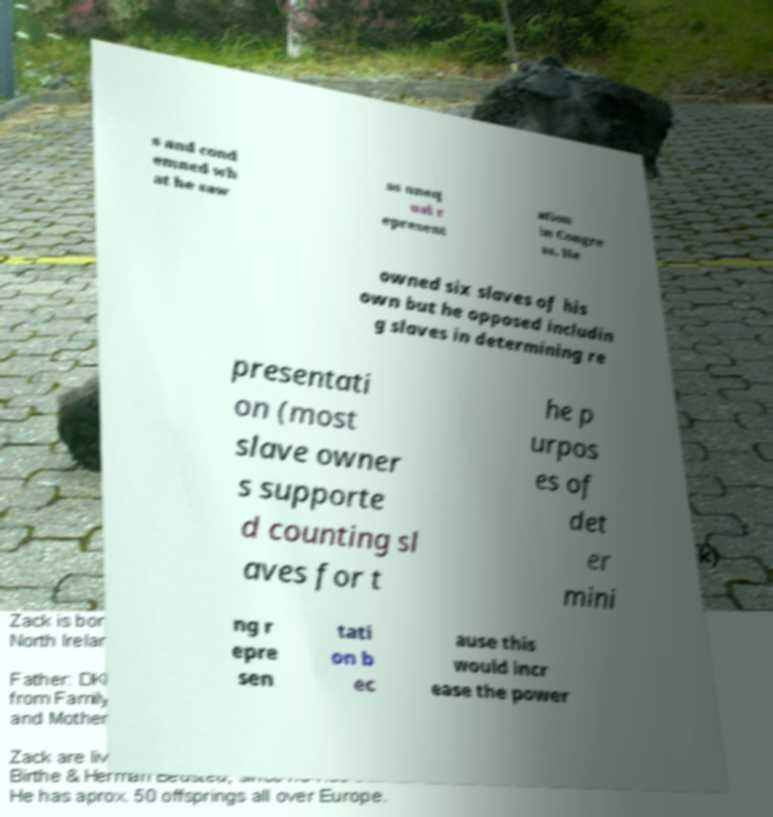Can you read and provide the text displayed in the image?This photo seems to have some interesting text. Can you extract and type it out for me? s and cond emned wh at he saw as uneq ual r epresent ation in Congre ss. He owned six slaves of his own but he opposed includin g slaves in determining re presentati on (most slave owner s supporte d counting sl aves for t he p urpos es of det er mini ng r epre sen tati on b ec ause this would incr ease the power 